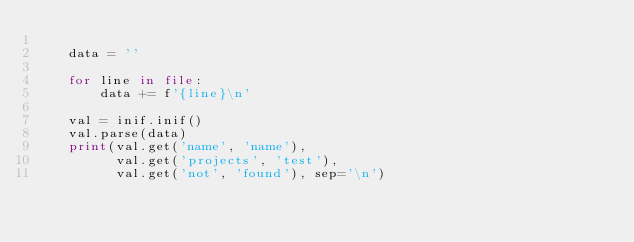<code> <loc_0><loc_0><loc_500><loc_500><_Python_>
    data = ''

    for line in file:
        data += f'{line}\n'

    val = inif.inif()
    val.parse(data)
    print(val.get('name', 'name'),
          val.get('projects', 'test'),
          val.get('not', 'found'), sep='\n')
</code> 